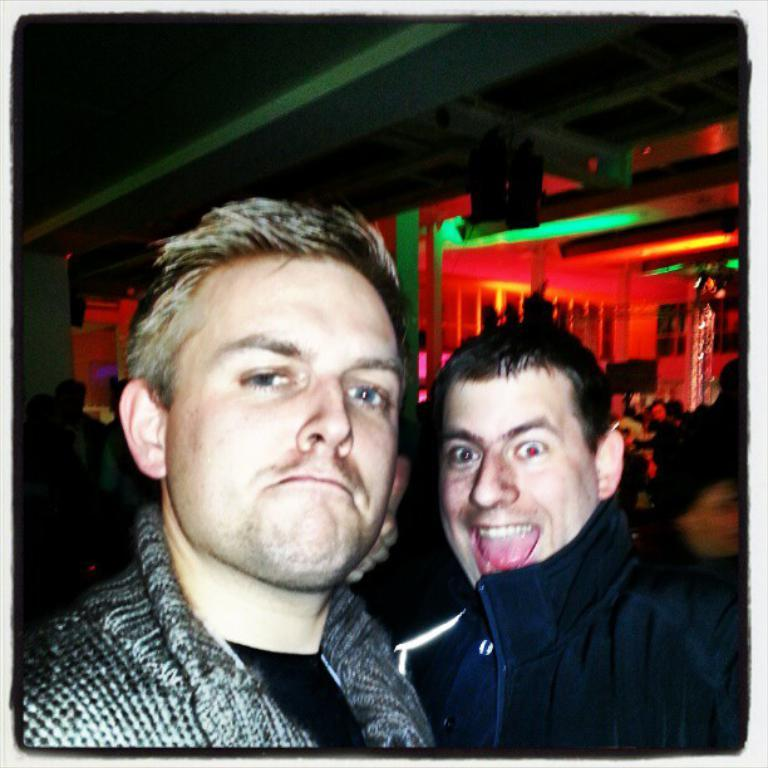How many people are in the image? There are two persons in the center of the image. What can be seen in the background of the image? There is a ceiling, lights, and a wall in the background of the image. What type of art is the snake creating on the wall in the image? There is no snake or art present in the image; it only features two persons and the background elements mentioned earlier. 